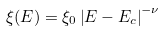<formula> <loc_0><loc_0><loc_500><loc_500>\xi ( E ) = \xi _ { 0 } \left | E - E _ { c } \right | ^ { - \nu }</formula> 